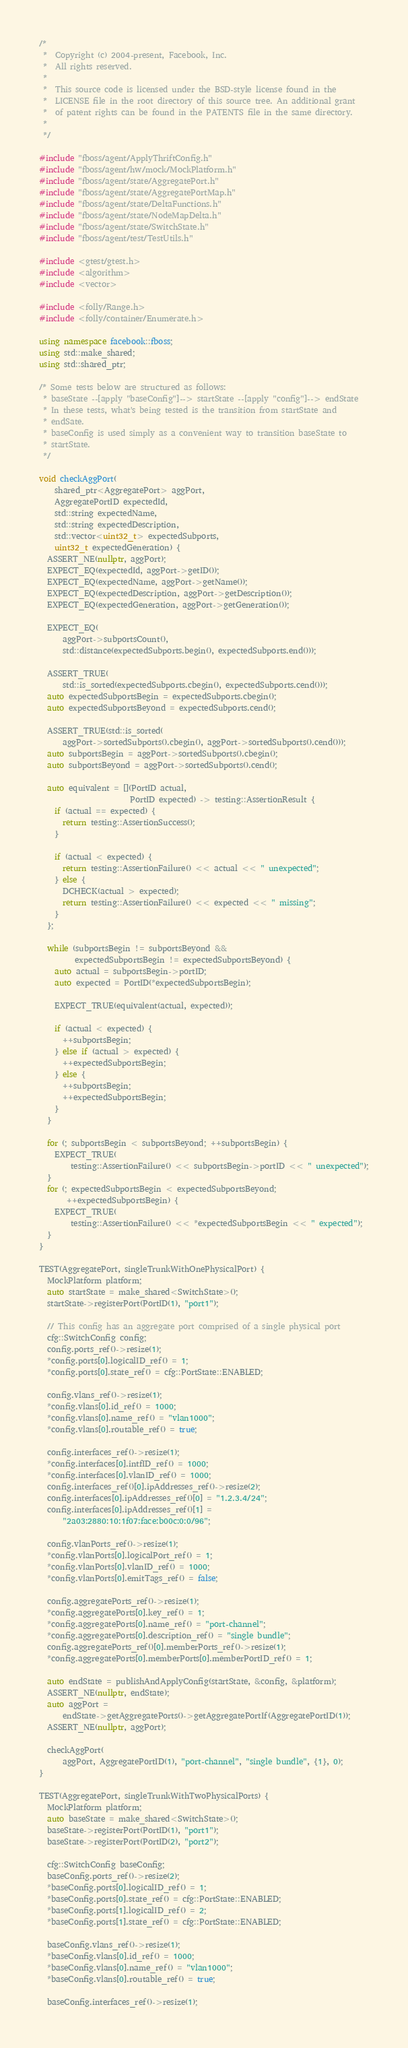Convert code to text. <code><loc_0><loc_0><loc_500><loc_500><_C++_>/*
 *  Copyright (c) 2004-present, Facebook, Inc.
 *  All rights reserved.
 *
 *  This source code is licensed under the BSD-style license found in the
 *  LICENSE file in the root directory of this source tree. An additional grant
 *  of patent rights can be found in the PATENTS file in the same directory.
 *
 */

#include "fboss/agent/ApplyThriftConfig.h"
#include "fboss/agent/hw/mock/MockPlatform.h"
#include "fboss/agent/state/AggregatePort.h"
#include "fboss/agent/state/AggregatePortMap.h"
#include "fboss/agent/state/DeltaFunctions.h"
#include "fboss/agent/state/NodeMapDelta.h"
#include "fboss/agent/state/SwitchState.h"
#include "fboss/agent/test/TestUtils.h"

#include <gtest/gtest.h>
#include <algorithm>
#include <vector>

#include <folly/Range.h>
#include <folly/container/Enumerate.h>

using namespace facebook::fboss;
using std::make_shared;
using std::shared_ptr;

/* Some tests below are structured as follows:
 * baseState --[apply "baseConfig"]--> startState --[apply "config"]--> endState
 * In these tests, what's being tested is the transition from startState and
 * endSate.
 * baseConfig is used simply as a convenient way to transition baseState to
 * startState.
 */

void checkAggPort(
    shared_ptr<AggregatePort> aggPort,
    AggregatePortID expectedId,
    std::string expectedName,
    std::string expectedDescription,
    std::vector<uint32_t> expectedSubports,
    uint32_t expectedGeneration) {
  ASSERT_NE(nullptr, aggPort);
  EXPECT_EQ(expectedId, aggPort->getID());
  EXPECT_EQ(expectedName, aggPort->getName());
  EXPECT_EQ(expectedDescription, aggPort->getDescription());
  EXPECT_EQ(expectedGeneration, aggPort->getGeneration());

  EXPECT_EQ(
      aggPort->subportsCount(),
      std::distance(expectedSubports.begin(), expectedSubports.end()));

  ASSERT_TRUE(
      std::is_sorted(expectedSubports.cbegin(), expectedSubports.cend()));
  auto expectedSubportsBegin = expectedSubports.cbegin();
  auto expectedSubportsBeyond = expectedSubports.cend();

  ASSERT_TRUE(std::is_sorted(
      aggPort->sortedSubports().cbegin(), aggPort->sortedSubports().cend()));
  auto subportsBegin = aggPort->sortedSubports().cbegin();
  auto subportsBeyond = aggPort->sortedSubports().cend();

  auto equivalent = [](PortID actual,
                       PortID expected) -> testing::AssertionResult {
    if (actual == expected) {
      return testing::AssertionSuccess();
    }

    if (actual < expected) {
      return testing::AssertionFailure() << actual << " unexpected";
    } else {
      DCHECK(actual > expected);
      return testing::AssertionFailure() << expected << " missing";
    }
  };

  while (subportsBegin != subportsBeyond &&
         expectedSubportsBegin != expectedSubportsBeyond) {
    auto actual = subportsBegin->portID;
    auto expected = PortID(*expectedSubportsBegin);

    EXPECT_TRUE(equivalent(actual, expected));

    if (actual < expected) {
      ++subportsBegin;
    } else if (actual > expected) {
      ++expectedSubportsBegin;
    } else {
      ++subportsBegin;
      ++expectedSubportsBegin;
    }
  }

  for (; subportsBegin < subportsBeyond; ++subportsBegin) {
    EXPECT_TRUE(
        testing::AssertionFailure() << subportsBegin->portID << " unexpected");
  }
  for (; expectedSubportsBegin < expectedSubportsBeyond;
       ++expectedSubportsBegin) {
    EXPECT_TRUE(
        testing::AssertionFailure() << *expectedSubportsBegin << " expected");
  }
}

TEST(AggregatePort, singleTrunkWithOnePhysicalPort) {
  MockPlatform platform;
  auto startState = make_shared<SwitchState>();
  startState->registerPort(PortID(1), "port1");

  // This config has an aggregate port comprised of a single physical port
  cfg::SwitchConfig config;
  config.ports_ref()->resize(1);
  *config.ports[0].logicalID_ref() = 1;
  *config.ports[0].state_ref() = cfg::PortState::ENABLED;

  config.vlans_ref()->resize(1);
  *config.vlans[0].id_ref() = 1000;
  *config.vlans[0].name_ref() = "vlan1000";
  *config.vlans[0].routable_ref() = true;

  config.interfaces_ref()->resize(1);
  *config.interfaces[0].intfID_ref() = 1000;
  *config.interfaces[0].vlanID_ref() = 1000;
  config.interfaces_ref()[0].ipAddresses_ref()->resize(2);
  config.interfaces[0].ipAddresses_ref()[0] = "1.2.3.4/24";
  config.interfaces[0].ipAddresses_ref()[1] =
      "2a03:2880:10:1f07:face:b00c:0:0/96";

  config.vlanPorts_ref()->resize(1);
  *config.vlanPorts[0].logicalPort_ref() = 1;
  *config.vlanPorts[0].vlanID_ref() = 1000;
  *config.vlanPorts[0].emitTags_ref() = false;

  config.aggregatePorts_ref()->resize(1);
  *config.aggregatePorts[0].key_ref() = 1;
  *config.aggregatePorts[0].name_ref() = "port-channel";
  *config.aggregatePorts[0].description_ref() = "single bundle";
  config.aggregatePorts_ref()[0].memberPorts_ref()->resize(1);
  *config.aggregatePorts[0].memberPorts[0].memberPortID_ref() = 1;

  auto endState = publishAndApplyConfig(startState, &config, &platform);
  ASSERT_NE(nullptr, endState);
  auto aggPort =
      endState->getAggregatePorts()->getAggregatePortIf(AggregatePortID(1));
  ASSERT_NE(nullptr, aggPort);

  checkAggPort(
      aggPort, AggregatePortID(1), "port-channel", "single bundle", {1}, 0);
}

TEST(AggregatePort, singleTrunkWithTwoPhysicalPorts) {
  MockPlatform platform;
  auto baseState = make_shared<SwitchState>();
  baseState->registerPort(PortID(1), "port1");
  baseState->registerPort(PortID(2), "port2");

  cfg::SwitchConfig baseConfig;
  baseConfig.ports_ref()->resize(2);
  *baseConfig.ports[0].logicalID_ref() = 1;
  *baseConfig.ports[0].state_ref() = cfg::PortState::ENABLED;
  *baseConfig.ports[1].logicalID_ref() = 2;
  *baseConfig.ports[1].state_ref() = cfg::PortState::ENABLED;

  baseConfig.vlans_ref()->resize(1);
  *baseConfig.vlans[0].id_ref() = 1000;
  *baseConfig.vlans[0].name_ref() = "vlan1000";
  *baseConfig.vlans[0].routable_ref() = true;

  baseConfig.interfaces_ref()->resize(1);</code> 